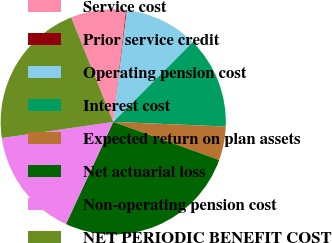Convert chart. <chart><loc_0><loc_0><loc_500><loc_500><pie_chart><fcel>Service cost<fcel>Prior service credit<fcel>Operating pension cost<fcel>Interest cost<fcel>Expected return on plan assets<fcel>Net actuarial loss<fcel>Non-operating pension cost<fcel>NET PERIODIC BENEFIT COST<nl><fcel>7.91%<fcel>0.12%<fcel>10.54%<fcel>13.17%<fcel>4.84%<fcel>26.4%<fcel>15.8%<fcel>21.2%<nl></chart> 